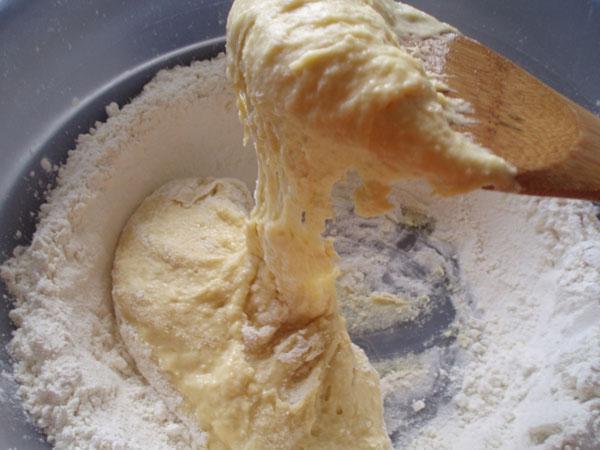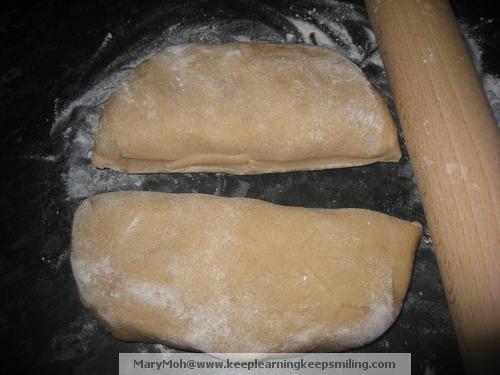The first image is the image on the left, the second image is the image on the right. Examine the images to the left and right. Is the description "A rolling pin is on a wooden cutting board." accurate? Answer yes or no. No. The first image is the image on the left, the second image is the image on the right. Assess this claim about the two images: "The left image shows dough in a roundish shape on a floured board, and the right image shows dough that has been flattened.". Correct or not? Answer yes or no. No. 